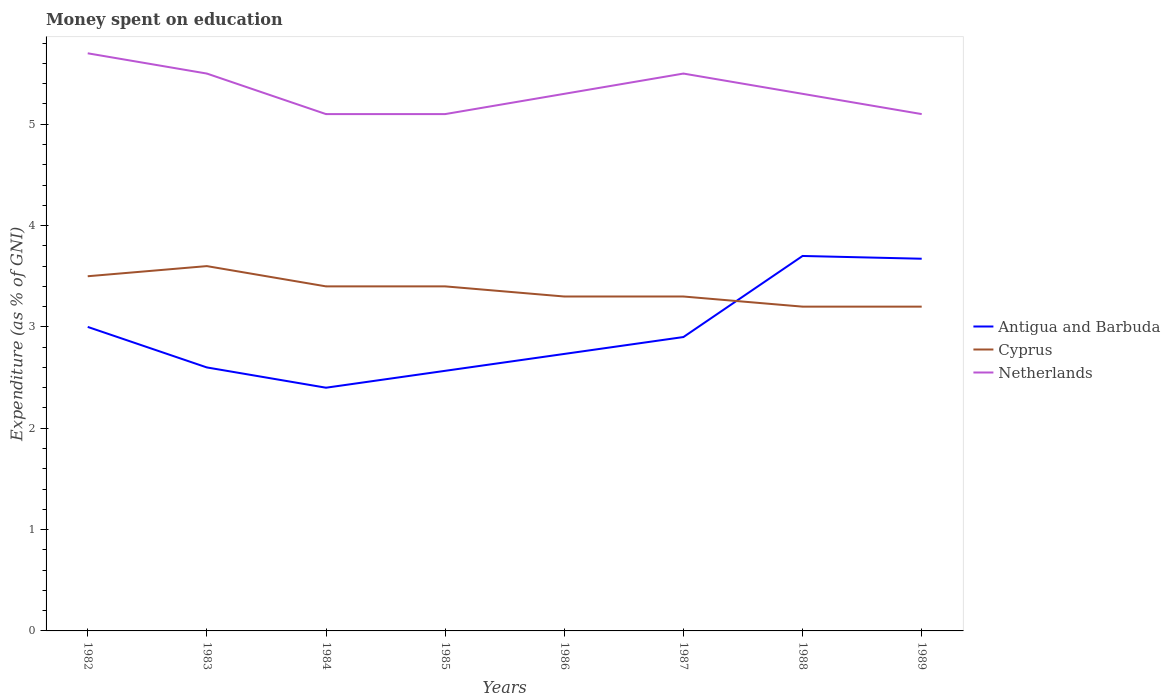How many different coloured lines are there?
Your answer should be compact. 3. Across all years, what is the maximum amount of money spent on education in Netherlands?
Give a very brief answer. 5.1. In which year was the amount of money spent on education in Netherlands maximum?
Make the answer very short. 1984. What is the total amount of money spent on education in Netherlands in the graph?
Make the answer very short. 0.6. What is the difference between the highest and the second highest amount of money spent on education in Antigua and Barbuda?
Offer a terse response. 1.3. Is the amount of money spent on education in Antigua and Barbuda strictly greater than the amount of money spent on education in Netherlands over the years?
Provide a short and direct response. Yes. How many lines are there?
Make the answer very short. 3. How many years are there in the graph?
Ensure brevity in your answer.  8. What is the difference between two consecutive major ticks on the Y-axis?
Keep it short and to the point. 1. Are the values on the major ticks of Y-axis written in scientific E-notation?
Give a very brief answer. No. Does the graph contain any zero values?
Ensure brevity in your answer.  No. Does the graph contain grids?
Your response must be concise. No. How many legend labels are there?
Offer a very short reply. 3. How are the legend labels stacked?
Offer a terse response. Vertical. What is the title of the graph?
Provide a succinct answer. Money spent on education. Does "Monaco" appear as one of the legend labels in the graph?
Ensure brevity in your answer.  No. What is the label or title of the Y-axis?
Keep it short and to the point. Expenditure (as % of GNI). What is the Expenditure (as % of GNI) of Antigua and Barbuda in 1982?
Offer a very short reply. 3. What is the Expenditure (as % of GNI) of Netherlands in 1982?
Your answer should be very brief. 5.7. What is the Expenditure (as % of GNI) in Antigua and Barbuda in 1983?
Offer a terse response. 2.6. What is the Expenditure (as % of GNI) of Antigua and Barbuda in 1984?
Your response must be concise. 2.4. What is the Expenditure (as % of GNI) in Netherlands in 1984?
Your response must be concise. 5.1. What is the Expenditure (as % of GNI) in Antigua and Barbuda in 1985?
Make the answer very short. 2.57. What is the Expenditure (as % of GNI) of Netherlands in 1985?
Your response must be concise. 5.1. What is the Expenditure (as % of GNI) in Antigua and Barbuda in 1986?
Your answer should be very brief. 2.73. What is the Expenditure (as % of GNI) of Cyprus in 1987?
Ensure brevity in your answer.  3.3. What is the Expenditure (as % of GNI) in Cyprus in 1988?
Your answer should be compact. 3.2. What is the Expenditure (as % of GNI) in Antigua and Barbuda in 1989?
Make the answer very short. 3.67. What is the Expenditure (as % of GNI) of Cyprus in 1989?
Keep it short and to the point. 3.2. Across all years, what is the maximum Expenditure (as % of GNI) in Cyprus?
Offer a very short reply. 3.6. Across all years, what is the maximum Expenditure (as % of GNI) in Netherlands?
Provide a short and direct response. 5.7. Across all years, what is the minimum Expenditure (as % of GNI) in Netherlands?
Provide a succinct answer. 5.1. What is the total Expenditure (as % of GNI) of Antigua and Barbuda in the graph?
Offer a terse response. 23.57. What is the total Expenditure (as % of GNI) of Cyprus in the graph?
Provide a short and direct response. 26.9. What is the total Expenditure (as % of GNI) in Netherlands in the graph?
Offer a very short reply. 42.6. What is the difference between the Expenditure (as % of GNI) in Cyprus in 1982 and that in 1983?
Offer a very short reply. -0.1. What is the difference between the Expenditure (as % of GNI) in Antigua and Barbuda in 1982 and that in 1984?
Your answer should be compact. 0.6. What is the difference between the Expenditure (as % of GNI) of Netherlands in 1982 and that in 1984?
Your answer should be very brief. 0.6. What is the difference between the Expenditure (as % of GNI) of Antigua and Barbuda in 1982 and that in 1985?
Your response must be concise. 0.43. What is the difference between the Expenditure (as % of GNI) of Netherlands in 1982 and that in 1985?
Your answer should be very brief. 0.6. What is the difference between the Expenditure (as % of GNI) in Antigua and Barbuda in 1982 and that in 1986?
Ensure brevity in your answer.  0.27. What is the difference between the Expenditure (as % of GNI) in Cyprus in 1982 and that in 1986?
Your response must be concise. 0.2. What is the difference between the Expenditure (as % of GNI) in Antigua and Barbuda in 1982 and that in 1987?
Offer a very short reply. 0.1. What is the difference between the Expenditure (as % of GNI) of Netherlands in 1982 and that in 1987?
Offer a terse response. 0.2. What is the difference between the Expenditure (as % of GNI) in Cyprus in 1982 and that in 1988?
Your answer should be very brief. 0.3. What is the difference between the Expenditure (as % of GNI) in Antigua and Barbuda in 1982 and that in 1989?
Your answer should be very brief. -0.67. What is the difference between the Expenditure (as % of GNI) of Cyprus in 1982 and that in 1989?
Your answer should be very brief. 0.3. What is the difference between the Expenditure (as % of GNI) of Antigua and Barbuda in 1983 and that in 1984?
Your answer should be compact. 0.2. What is the difference between the Expenditure (as % of GNI) of Cyprus in 1983 and that in 1984?
Keep it short and to the point. 0.2. What is the difference between the Expenditure (as % of GNI) of Netherlands in 1983 and that in 1985?
Your response must be concise. 0.4. What is the difference between the Expenditure (as % of GNI) of Antigua and Barbuda in 1983 and that in 1986?
Your answer should be very brief. -0.13. What is the difference between the Expenditure (as % of GNI) in Cyprus in 1983 and that in 1986?
Ensure brevity in your answer.  0.3. What is the difference between the Expenditure (as % of GNI) of Netherlands in 1983 and that in 1987?
Keep it short and to the point. 0. What is the difference between the Expenditure (as % of GNI) of Antigua and Barbuda in 1983 and that in 1988?
Ensure brevity in your answer.  -1.1. What is the difference between the Expenditure (as % of GNI) of Cyprus in 1983 and that in 1988?
Your answer should be very brief. 0.4. What is the difference between the Expenditure (as % of GNI) in Antigua and Barbuda in 1983 and that in 1989?
Provide a short and direct response. -1.07. What is the difference between the Expenditure (as % of GNI) of Netherlands in 1984 and that in 1985?
Ensure brevity in your answer.  0. What is the difference between the Expenditure (as % of GNI) of Antigua and Barbuda in 1984 and that in 1986?
Your response must be concise. -0.33. What is the difference between the Expenditure (as % of GNI) of Antigua and Barbuda in 1984 and that in 1987?
Your answer should be very brief. -0.5. What is the difference between the Expenditure (as % of GNI) in Netherlands in 1984 and that in 1987?
Your answer should be compact. -0.4. What is the difference between the Expenditure (as % of GNI) in Antigua and Barbuda in 1984 and that in 1988?
Make the answer very short. -1.3. What is the difference between the Expenditure (as % of GNI) in Netherlands in 1984 and that in 1988?
Provide a succinct answer. -0.2. What is the difference between the Expenditure (as % of GNI) in Antigua and Barbuda in 1984 and that in 1989?
Your answer should be very brief. -1.27. What is the difference between the Expenditure (as % of GNI) in Cyprus in 1984 and that in 1989?
Ensure brevity in your answer.  0.2. What is the difference between the Expenditure (as % of GNI) in Antigua and Barbuda in 1985 and that in 1986?
Keep it short and to the point. -0.17. What is the difference between the Expenditure (as % of GNI) of Cyprus in 1985 and that in 1986?
Ensure brevity in your answer.  0.1. What is the difference between the Expenditure (as % of GNI) of Cyprus in 1985 and that in 1987?
Give a very brief answer. 0.1. What is the difference between the Expenditure (as % of GNI) in Antigua and Barbuda in 1985 and that in 1988?
Your answer should be very brief. -1.13. What is the difference between the Expenditure (as % of GNI) in Netherlands in 1985 and that in 1988?
Your answer should be very brief. -0.2. What is the difference between the Expenditure (as % of GNI) in Antigua and Barbuda in 1985 and that in 1989?
Provide a short and direct response. -1.11. What is the difference between the Expenditure (as % of GNI) of Cyprus in 1985 and that in 1989?
Offer a very short reply. 0.2. What is the difference between the Expenditure (as % of GNI) in Antigua and Barbuda in 1986 and that in 1987?
Provide a succinct answer. -0.17. What is the difference between the Expenditure (as % of GNI) of Netherlands in 1986 and that in 1987?
Keep it short and to the point. -0.2. What is the difference between the Expenditure (as % of GNI) in Antigua and Barbuda in 1986 and that in 1988?
Make the answer very short. -0.97. What is the difference between the Expenditure (as % of GNI) of Netherlands in 1986 and that in 1988?
Keep it short and to the point. 0. What is the difference between the Expenditure (as % of GNI) in Antigua and Barbuda in 1986 and that in 1989?
Provide a short and direct response. -0.94. What is the difference between the Expenditure (as % of GNI) in Cyprus in 1986 and that in 1989?
Keep it short and to the point. 0.1. What is the difference between the Expenditure (as % of GNI) in Antigua and Barbuda in 1987 and that in 1988?
Provide a short and direct response. -0.8. What is the difference between the Expenditure (as % of GNI) of Cyprus in 1987 and that in 1988?
Offer a very short reply. 0.1. What is the difference between the Expenditure (as % of GNI) of Antigua and Barbuda in 1987 and that in 1989?
Your answer should be compact. -0.77. What is the difference between the Expenditure (as % of GNI) of Cyprus in 1987 and that in 1989?
Provide a short and direct response. 0.1. What is the difference between the Expenditure (as % of GNI) in Antigua and Barbuda in 1988 and that in 1989?
Give a very brief answer. 0.03. What is the difference between the Expenditure (as % of GNI) in Antigua and Barbuda in 1982 and the Expenditure (as % of GNI) in Cyprus in 1983?
Your response must be concise. -0.6. What is the difference between the Expenditure (as % of GNI) in Antigua and Barbuda in 1982 and the Expenditure (as % of GNI) in Netherlands in 1983?
Give a very brief answer. -2.5. What is the difference between the Expenditure (as % of GNI) in Cyprus in 1982 and the Expenditure (as % of GNI) in Netherlands in 1983?
Provide a succinct answer. -2. What is the difference between the Expenditure (as % of GNI) in Antigua and Barbuda in 1982 and the Expenditure (as % of GNI) in Cyprus in 1984?
Ensure brevity in your answer.  -0.4. What is the difference between the Expenditure (as % of GNI) in Antigua and Barbuda in 1982 and the Expenditure (as % of GNI) in Netherlands in 1984?
Give a very brief answer. -2.1. What is the difference between the Expenditure (as % of GNI) of Antigua and Barbuda in 1982 and the Expenditure (as % of GNI) of Netherlands in 1985?
Your answer should be very brief. -2.1. What is the difference between the Expenditure (as % of GNI) in Cyprus in 1982 and the Expenditure (as % of GNI) in Netherlands in 1985?
Provide a short and direct response. -1.6. What is the difference between the Expenditure (as % of GNI) in Antigua and Barbuda in 1982 and the Expenditure (as % of GNI) in Cyprus in 1986?
Your answer should be very brief. -0.3. What is the difference between the Expenditure (as % of GNI) of Antigua and Barbuda in 1982 and the Expenditure (as % of GNI) of Netherlands in 1986?
Offer a terse response. -2.3. What is the difference between the Expenditure (as % of GNI) in Cyprus in 1982 and the Expenditure (as % of GNI) in Netherlands in 1986?
Make the answer very short. -1.8. What is the difference between the Expenditure (as % of GNI) of Antigua and Barbuda in 1982 and the Expenditure (as % of GNI) of Cyprus in 1987?
Your answer should be very brief. -0.3. What is the difference between the Expenditure (as % of GNI) of Antigua and Barbuda in 1982 and the Expenditure (as % of GNI) of Cyprus in 1988?
Your response must be concise. -0.2. What is the difference between the Expenditure (as % of GNI) of Antigua and Barbuda in 1982 and the Expenditure (as % of GNI) of Netherlands in 1989?
Ensure brevity in your answer.  -2.1. What is the difference between the Expenditure (as % of GNI) of Antigua and Barbuda in 1983 and the Expenditure (as % of GNI) of Cyprus in 1984?
Provide a short and direct response. -0.8. What is the difference between the Expenditure (as % of GNI) of Cyprus in 1983 and the Expenditure (as % of GNI) of Netherlands in 1984?
Provide a succinct answer. -1.5. What is the difference between the Expenditure (as % of GNI) of Cyprus in 1983 and the Expenditure (as % of GNI) of Netherlands in 1985?
Provide a short and direct response. -1.5. What is the difference between the Expenditure (as % of GNI) in Cyprus in 1983 and the Expenditure (as % of GNI) in Netherlands in 1986?
Ensure brevity in your answer.  -1.7. What is the difference between the Expenditure (as % of GNI) in Antigua and Barbuda in 1983 and the Expenditure (as % of GNI) in Netherlands in 1988?
Make the answer very short. -2.7. What is the difference between the Expenditure (as % of GNI) in Cyprus in 1983 and the Expenditure (as % of GNI) in Netherlands in 1988?
Provide a succinct answer. -1.7. What is the difference between the Expenditure (as % of GNI) of Antigua and Barbuda in 1983 and the Expenditure (as % of GNI) of Cyprus in 1989?
Ensure brevity in your answer.  -0.6. What is the difference between the Expenditure (as % of GNI) of Antigua and Barbuda in 1983 and the Expenditure (as % of GNI) of Netherlands in 1989?
Ensure brevity in your answer.  -2.5. What is the difference between the Expenditure (as % of GNI) of Antigua and Barbuda in 1984 and the Expenditure (as % of GNI) of Cyprus in 1985?
Offer a very short reply. -1. What is the difference between the Expenditure (as % of GNI) of Antigua and Barbuda in 1984 and the Expenditure (as % of GNI) of Netherlands in 1985?
Ensure brevity in your answer.  -2.7. What is the difference between the Expenditure (as % of GNI) of Cyprus in 1984 and the Expenditure (as % of GNI) of Netherlands in 1986?
Provide a short and direct response. -1.9. What is the difference between the Expenditure (as % of GNI) of Antigua and Barbuda in 1984 and the Expenditure (as % of GNI) of Cyprus in 1987?
Offer a very short reply. -0.9. What is the difference between the Expenditure (as % of GNI) in Antigua and Barbuda in 1984 and the Expenditure (as % of GNI) in Netherlands in 1987?
Give a very brief answer. -3.1. What is the difference between the Expenditure (as % of GNI) of Cyprus in 1984 and the Expenditure (as % of GNI) of Netherlands in 1987?
Offer a very short reply. -2.1. What is the difference between the Expenditure (as % of GNI) of Cyprus in 1984 and the Expenditure (as % of GNI) of Netherlands in 1989?
Your answer should be compact. -1.7. What is the difference between the Expenditure (as % of GNI) of Antigua and Barbuda in 1985 and the Expenditure (as % of GNI) of Cyprus in 1986?
Your answer should be very brief. -0.73. What is the difference between the Expenditure (as % of GNI) in Antigua and Barbuda in 1985 and the Expenditure (as % of GNI) in Netherlands in 1986?
Offer a terse response. -2.73. What is the difference between the Expenditure (as % of GNI) of Antigua and Barbuda in 1985 and the Expenditure (as % of GNI) of Cyprus in 1987?
Your answer should be very brief. -0.73. What is the difference between the Expenditure (as % of GNI) of Antigua and Barbuda in 1985 and the Expenditure (as % of GNI) of Netherlands in 1987?
Provide a succinct answer. -2.93. What is the difference between the Expenditure (as % of GNI) of Cyprus in 1985 and the Expenditure (as % of GNI) of Netherlands in 1987?
Your response must be concise. -2.1. What is the difference between the Expenditure (as % of GNI) of Antigua and Barbuda in 1985 and the Expenditure (as % of GNI) of Cyprus in 1988?
Ensure brevity in your answer.  -0.63. What is the difference between the Expenditure (as % of GNI) in Antigua and Barbuda in 1985 and the Expenditure (as % of GNI) in Netherlands in 1988?
Ensure brevity in your answer.  -2.73. What is the difference between the Expenditure (as % of GNI) of Antigua and Barbuda in 1985 and the Expenditure (as % of GNI) of Cyprus in 1989?
Make the answer very short. -0.63. What is the difference between the Expenditure (as % of GNI) of Antigua and Barbuda in 1985 and the Expenditure (as % of GNI) of Netherlands in 1989?
Ensure brevity in your answer.  -2.53. What is the difference between the Expenditure (as % of GNI) of Antigua and Barbuda in 1986 and the Expenditure (as % of GNI) of Cyprus in 1987?
Give a very brief answer. -0.57. What is the difference between the Expenditure (as % of GNI) in Antigua and Barbuda in 1986 and the Expenditure (as % of GNI) in Netherlands in 1987?
Ensure brevity in your answer.  -2.77. What is the difference between the Expenditure (as % of GNI) of Cyprus in 1986 and the Expenditure (as % of GNI) of Netherlands in 1987?
Provide a short and direct response. -2.2. What is the difference between the Expenditure (as % of GNI) in Antigua and Barbuda in 1986 and the Expenditure (as % of GNI) in Cyprus in 1988?
Keep it short and to the point. -0.47. What is the difference between the Expenditure (as % of GNI) in Antigua and Barbuda in 1986 and the Expenditure (as % of GNI) in Netherlands in 1988?
Your response must be concise. -2.57. What is the difference between the Expenditure (as % of GNI) in Antigua and Barbuda in 1986 and the Expenditure (as % of GNI) in Cyprus in 1989?
Offer a terse response. -0.47. What is the difference between the Expenditure (as % of GNI) of Antigua and Barbuda in 1986 and the Expenditure (as % of GNI) of Netherlands in 1989?
Provide a short and direct response. -2.37. What is the difference between the Expenditure (as % of GNI) of Cyprus in 1987 and the Expenditure (as % of GNI) of Netherlands in 1988?
Keep it short and to the point. -2. What is the difference between the Expenditure (as % of GNI) in Antigua and Barbuda in 1988 and the Expenditure (as % of GNI) in Netherlands in 1989?
Your answer should be very brief. -1.4. What is the average Expenditure (as % of GNI) in Antigua and Barbuda per year?
Ensure brevity in your answer.  2.95. What is the average Expenditure (as % of GNI) of Cyprus per year?
Your response must be concise. 3.36. What is the average Expenditure (as % of GNI) of Netherlands per year?
Give a very brief answer. 5.33. In the year 1982, what is the difference between the Expenditure (as % of GNI) of Antigua and Barbuda and Expenditure (as % of GNI) of Cyprus?
Make the answer very short. -0.5. In the year 1983, what is the difference between the Expenditure (as % of GNI) of Antigua and Barbuda and Expenditure (as % of GNI) of Cyprus?
Make the answer very short. -1. In the year 1983, what is the difference between the Expenditure (as % of GNI) of Antigua and Barbuda and Expenditure (as % of GNI) of Netherlands?
Offer a terse response. -2.9. In the year 1983, what is the difference between the Expenditure (as % of GNI) of Cyprus and Expenditure (as % of GNI) of Netherlands?
Ensure brevity in your answer.  -1.9. In the year 1984, what is the difference between the Expenditure (as % of GNI) of Antigua and Barbuda and Expenditure (as % of GNI) of Cyprus?
Offer a terse response. -1. In the year 1984, what is the difference between the Expenditure (as % of GNI) of Antigua and Barbuda and Expenditure (as % of GNI) of Netherlands?
Offer a very short reply. -2.7. In the year 1984, what is the difference between the Expenditure (as % of GNI) in Cyprus and Expenditure (as % of GNI) in Netherlands?
Your answer should be compact. -1.7. In the year 1985, what is the difference between the Expenditure (as % of GNI) of Antigua and Barbuda and Expenditure (as % of GNI) of Cyprus?
Your response must be concise. -0.83. In the year 1985, what is the difference between the Expenditure (as % of GNI) of Antigua and Barbuda and Expenditure (as % of GNI) of Netherlands?
Your response must be concise. -2.53. In the year 1986, what is the difference between the Expenditure (as % of GNI) of Antigua and Barbuda and Expenditure (as % of GNI) of Cyprus?
Make the answer very short. -0.57. In the year 1986, what is the difference between the Expenditure (as % of GNI) of Antigua and Barbuda and Expenditure (as % of GNI) of Netherlands?
Make the answer very short. -2.57. In the year 1987, what is the difference between the Expenditure (as % of GNI) in Antigua and Barbuda and Expenditure (as % of GNI) in Netherlands?
Provide a succinct answer. -2.6. In the year 1987, what is the difference between the Expenditure (as % of GNI) of Cyprus and Expenditure (as % of GNI) of Netherlands?
Offer a very short reply. -2.2. In the year 1988, what is the difference between the Expenditure (as % of GNI) in Antigua and Barbuda and Expenditure (as % of GNI) in Cyprus?
Keep it short and to the point. 0.5. In the year 1988, what is the difference between the Expenditure (as % of GNI) in Antigua and Barbuda and Expenditure (as % of GNI) in Netherlands?
Keep it short and to the point. -1.6. In the year 1988, what is the difference between the Expenditure (as % of GNI) in Cyprus and Expenditure (as % of GNI) in Netherlands?
Your answer should be compact. -2.1. In the year 1989, what is the difference between the Expenditure (as % of GNI) of Antigua and Barbuda and Expenditure (as % of GNI) of Cyprus?
Provide a succinct answer. 0.47. In the year 1989, what is the difference between the Expenditure (as % of GNI) in Antigua and Barbuda and Expenditure (as % of GNI) in Netherlands?
Make the answer very short. -1.43. What is the ratio of the Expenditure (as % of GNI) in Antigua and Barbuda in 1982 to that in 1983?
Provide a succinct answer. 1.15. What is the ratio of the Expenditure (as % of GNI) of Cyprus in 1982 to that in 1983?
Give a very brief answer. 0.97. What is the ratio of the Expenditure (as % of GNI) in Netherlands in 1982 to that in 1983?
Give a very brief answer. 1.04. What is the ratio of the Expenditure (as % of GNI) in Cyprus in 1982 to that in 1984?
Give a very brief answer. 1.03. What is the ratio of the Expenditure (as % of GNI) in Netherlands in 1982 to that in 1984?
Ensure brevity in your answer.  1.12. What is the ratio of the Expenditure (as % of GNI) of Antigua and Barbuda in 1982 to that in 1985?
Your answer should be compact. 1.17. What is the ratio of the Expenditure (as % of GNI) in Cyprus in 1982 to that in 1985?
Provide a succinct answer. 1.03. What is the ratio of the Expenditure (as % of GNI) in Netherlands in 1982 to that in 1985?
Keep it short and to the point. 1.12. What is the ratio of the Expenditure (as % of GNI) in Antigua and Barbuda in 1982 to that in 1986?
Offer a terse response. 1.1. What is the ratio of the Expenditure (as % of GNI) in Cyprus in 1982 to that in 1986?
Give a very brief answer. 1.06. What is the ratio of the Expenditure (as % of GNI) of Netherlands in 1982 to that in 1986?
Offer a very short reply. 1.08. What is the ratio of the Expenditure (as % of GNI) in Antigua and Barbuda in 1982 to that in 1987?
Provide a short and direct response. 1.03. What is the ratio of the Expenditure (as % of GNI) in Cyprus in 1982 to that in 1987?
Offer a very short reply. 1.06. What is the ratio of the Expenditure (as % of GNI) in Netherlands in 1982 to that in 1987?
Make the answer very short. 1.04. What is the ratio of the Expenditure (as % of GNI) of Antigua and Barbuda in 1982 to that in 1988?
Ensure brevity in your answer.  0.81. What is the ratio of the Expenditure (as % of GNI) of Cyprus in 1982 to that in 1988?
Provide a short and direct response. 1.09. What is the ratio of the Expenditure (as % of GNI) of Netherlands in 1982 to that in 1988?
Offer a terse response. 1.08. What is the ratio of the Expenditure (as % of GNI) of Antigua and Barbuda in 1982 to that in 1989?
Keep it short and to the point. 0.82. What is the ratio of the Expenditure (as % of GNI) in Cyprus in 1982 to that in 1989?
Make the answer very short. 1.09. What is the ratio of the Expenditure (as % of GNI) in Netherlands in 1982 to that in 1989?
Keep it short and to the point. 1.12. What is the ratio of the Expenditure (as % of GNI) of Antigua and Barbuda in 1983 to that in 1984?
Offer a terse response. 1.08. What is the ratio of the Expenditure (as % of GNI) in Cyprus in 1983 to that in 1984?
Your answer should be very brief. 1.06. What is the ratio of the Expenditure (as % of GNI) of Netherlands in 1983 to that in 1984?
Offer a very short reply. 1.08. What is the ratio of the Expenditure (as % of GNI) in Antigua and Barbuda in 1983 to that in 1985?
Your answer should be very brief. 1.01. What is the ratio of the Expenditure (as % of GNI) in Cyprus in 1983 to that in 1985?
Give a very brief answer. 1.06. What is the ratio of the Expenditure (as % of GNI) in Netherlands in 1983 to that in 1985?
Provide a short and direct response. 1.08. What is the ratio of the Expenditure (as % of GNI) in Antigua and Barbuda in 1983 to that in 1986?
Make the answer very short. 0.95. What is the ratio of the Expenditure (as % of GNI) of Cyprus in 1983 to that in 1986?
Your answer should be very brief. 1.09. What is the ratio of the Expenditure (as % of GNI) in Netherlands in 1983 to that in 1986?
Provide a succinct answer. 1.04. What is the ratio of the Expenditure (as % of GNI) of Antigua and Barbuda in 1983 to that in 1987?
Your answer should be very brief. 0.9. What is the ratio of the Expenditure (as % of GNI) of Cyprus in 1983 to that in 1987?
Ensure brevity in your answer.  1.09. What is the ratio of the Expenditure (as % of GNI) of Antigua and Barbuda in 1983 to that in 1988?
Your answer should be compact. 0.7. What is the ratio of the Expenditure (as % of GNI) in Netherlands in 1983 to that in 1988?
Offer a terse response. 1.04. What is the ratio of the Expenditure (as % of GNI) in Antigua and Barbuda in 1983 to that in 1989?
Give a very brief answer. 0.71. What is the ratio of the Expenditure (as % of GNI) in Cyprus in 1983 to that in 1989?
Make the answer very short. 1.12. What is the ratio of the Expenditure (as % of GNI) in Netherlands in 1983 to that in 1989?
Offer a terse response. 1.08. What is the ratio of the Expenditure (as % of GNI) in Antigua and Barbuda in 1984 to that in 1985?
Your answer should be very brief. 0.94. What is the ratio of the Expenditure (as % of GNI) in Cyprus in 1984 to that in 1985?
Give a very brief answer. 1. What is the ratio of the Expenditure (as % of GNI) in Antigua and Barbuda in 1984 to that in 1986?
Give a very brief answer. 0.88. What is the ratio of the Expenditure (as % of GNI) in Cyprus in 1984 to that in 1986?
Give a very brief answer. 1.03. What is the ratio of the Expenditure (as % of GNI) in Netherlands in 1984 to that in 1986?
Offer a terse response. 0.96. What is the ratio of the Expenditure (as % of GNI) of Antigua and Barbuda in 1984 to that in 1987?
Ensure brevity in your answer.  0.83. What is the ratio of the Expenditure (as % of GNI) of Cyprus in 1984 to that in 1987?
Give a very brief answer. 1.03. What is the ratio of the Expenditure (as % of GNI) of Netherlands in 1984 to that in 1987?
Give a very brief answer. 0.93. What is the ratio of the Expenditure (as % of GNI) in Antigua and Barbuda in 1984 to that in 1988?
Offer a terse response. 0.65. What is the ratio of the Expenditure (as % of GNI) in Cyprus in 1984 to that in 1988?
Offer a terse response. 1.06. What is the ratio of the Expenditure (as % of GNI) in Netherlands in 1984 to that in 1988?
Keep it short and to the point. 0.96. What is the ratio of the Expenditure (as % of GNI) of Antigua and Barbuda in 1984 to that in 1989?
Provide a succinct answer. 0.65. What is the ratio of the Expenditure (as % of GNI) in Netherlands in 1984 to that in 1989?
Keep it short and to the point. 1. What is the ratio of the Expenditure (as % of GNI) of Antigua and Barbuda in 1985 to that in 1986?
Offer a very short reply. 0.94. What is the ratio of the Expenditure (as % of GNI) in Cyprus in 1985 to that in 1986?
Keep it short and to the point. 1.03. What is the ratio of the Expenditure (as % of GNI) in Netherlands in 1985 to that in 1986?
Provide a short and direct response. 0.96. What is the ratio of the Expenditure (as % of GNI) in Antigua and Barbuda in 1985 to that in 1987?
Ensure brevity in your answer.  0.89. What is the ratio of the Expenditure (as % of GNI) of Cyprus in 1985 to that in 1987?
Give a very brief answer. 1.03. What is the ratio of the Expenditure (as % of GNI) of Netherlands in 1985 to that in 1987?
Offer a very short reply. 0.93. What is the ratio of the Expenditure (as % of GNI) of Antigua and Barbuda in 1985 to that in 1988?
Keep it short and to the point. 0.69. What is the ratio of the Expenditure (as % of GNI) of Cyprus in 1985 to that in 1988?
Your answer should be compact. 1.06. What is the ratio of the Expenditure (as % of GNI) of Netherlands in 1985 to that in 1988?
Your answer should be very brief. 0.96. What is the ratio of the Expenditure (as % of GNI) in Antigua and Barbuda in 1985 to that in 1989?
Offer a terse response. 0.7. What is the ratio of the Expenditure (as % of GNI) in Cyprus in 1985 to that in 1989?
Your answer should be very brief. 1.06. What is the ratio of the Expenditure (as % of GNI) in Antigua and Barbuda in 1986 to that in 1987?
Provide a succinct answer. 0.94. What is the ratio of the Expenditure (as % of GNI) in Cyprus in 1986 to that in 1987?
Your answer should be compact. 1. What is the ratio of the Expenditure (as % of GNI) of Netherlands in 1986 to that in 1987?
Keep it short and to the point. 0.96. What is the ratio of the Expenditure (as % of GNI) in Antigua and Barbuda in 1986 to that in 1988?
Your answer should be compact. 0.74. What is the ratio of the Expenditure (as % of GNI) in Cyprus in 1986 to that in 1988?
Provide a short and direct response. 1.03. What is the ratio of the Expenditure (as % of GNI) in Netherlands in 1986 to that in 1988?
Provide a succinct answer. 1. What is the ratio of the Expenditure (as % of GNI) in Antigua and Barbuda in 1986 to that in 1989?
Offer a very short reply. 0.74. What is the ratio of the Expenditure (as % of GNI) in Cyprus in 1986 to that in 1989?
Give a very brief answer. 1.03. What is the ratio of the Expenditure (as % of GNI) in Netherlands in 1986 to that in 1989?
Ensure brevity in your answer.  1.04. What is the ratio of the Expenditure (as % of GNI) in Antigua and Barbuda in 1987 to that in 1988?
Ensure brevity in your answer.  0.78. What is the ratio of the Expenditure (as % of GNI) of Cyprus in 1987 to that in 1988?
Your response must be concise. 1.03. What is the ratio of the Expenditure (as % of GNI) of Netherlands in 1987 to that in 1988?
Provide a succinct answer. 1.04. What is the ratio of the Expenditure (as % of GNI) in Antigua and Barbuda in 1987 to that in 1989?
Make the answer very short. 0.79. What is the ratio of the Expenditure (as % of GNI) of Cyprus in 1987 to that in 1989?
Your answer should be compact. 1.03. What is the ratio of the Expenditure (as % of GNI) in Netherlands in 1987 to that in 1989?
Ensure brevity in your answer.  1.08. What is the ratio of the Expenditure (as % of GNI) in Antigua and Barbuda in 1988 to that in 1989?
Make the answer very short. 1.01. What is the ratio of the Expenditure (as % of GNI) in Cyprus in 1988 to that in 1989?
Make the answer very short. 1. What is the ratio of the Expenditure (as % of GNI) of Netherlands in 1988 to that in 1989?
Your answer should be very brief. 1.04. What is the difference between the highest and the second highest Expenditure (as % of GNI) of Antigua and Barbuda?
Keep it short and to the point. 0.03. What is the difference between the highest and the second highest Expenditure (as % of GNI) in Cyprus?
Make the answer very short. 0.1. 